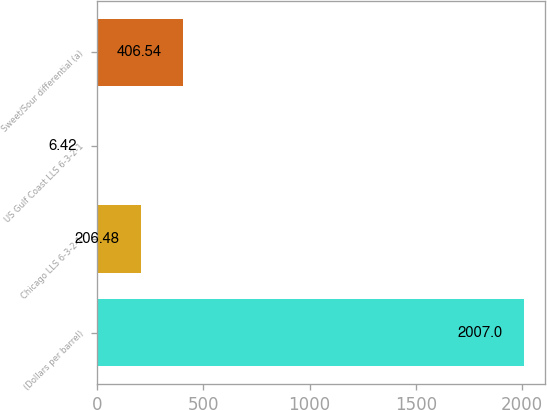<chart> <loc_0><loc_0><loc_500><loc_500><bar_chart><fcel>(Dollars per barrel)<fcel>Chicago LLS 6-3-2-1<fcel>US Gulf Coast LLS 6-3-2-1<fcel>Sweet/Sour differential (a)<nl><fcel>2007<fcel>206.48<fcel>6.42<fcel>406.54<nl></chart> 